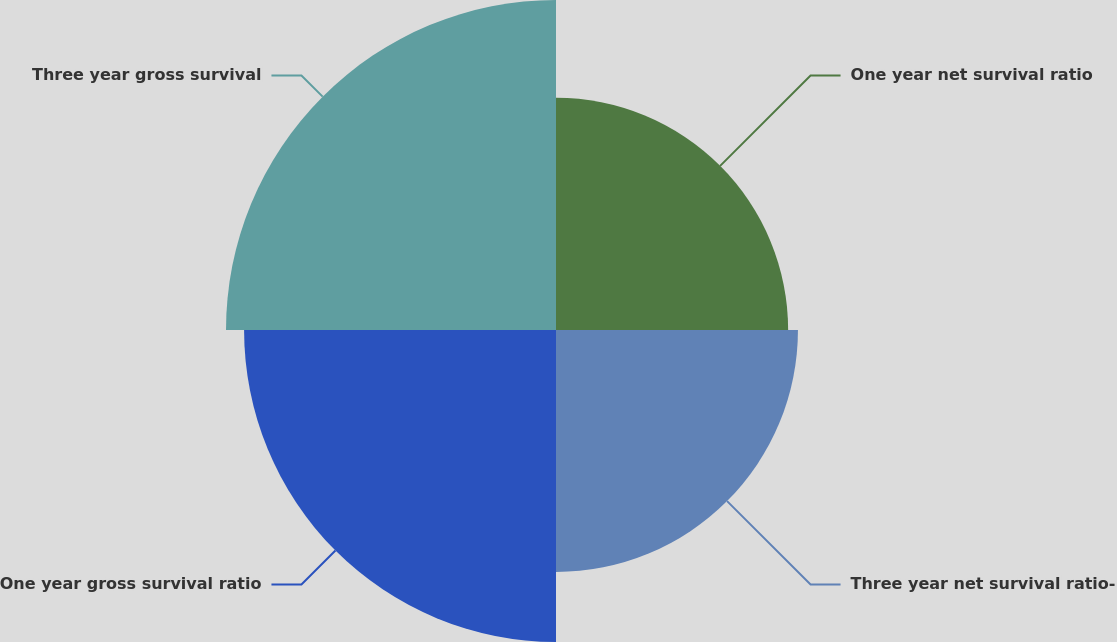Convert chart to OTSL. <chart><loc_0><loc_0><loc_500><loc_500><pie_chart><fcel>One year net survival ratio<fcel>Three year net survival ratio-<fcel>One year gross survival ratio<fcel>Three year gross survival<nl><fcel>20.8%<fcel>21.68%<fcel>27.95%<fcel>29.57%<nl></chart> 